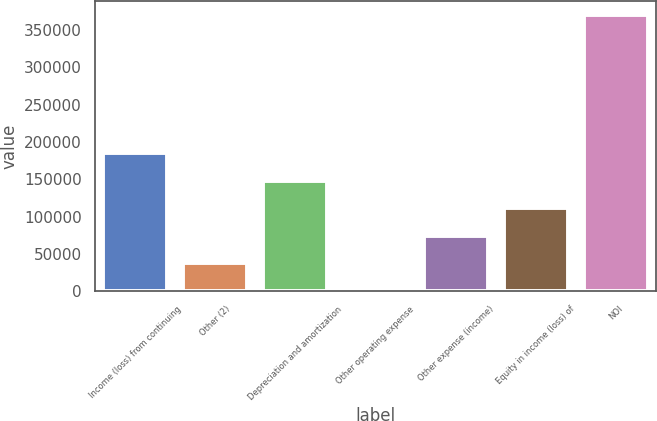<chart> <loc_0><loc_0><loc_500><loc_500><bar_chart><fcel>Income (loss) from continuing<fcel>Other (2)<fcel>Depreciation and amortization<fcel>Other operating expense<fcel>Other expense (income)<fcel>Equity in income (loss) of<fcel>NOI<nl><fcel>185152<fcel>37292.7<fcel>148187<fcel>328<fcel>74257.4<fcel>111222<fcel>369975<nl></chart> 